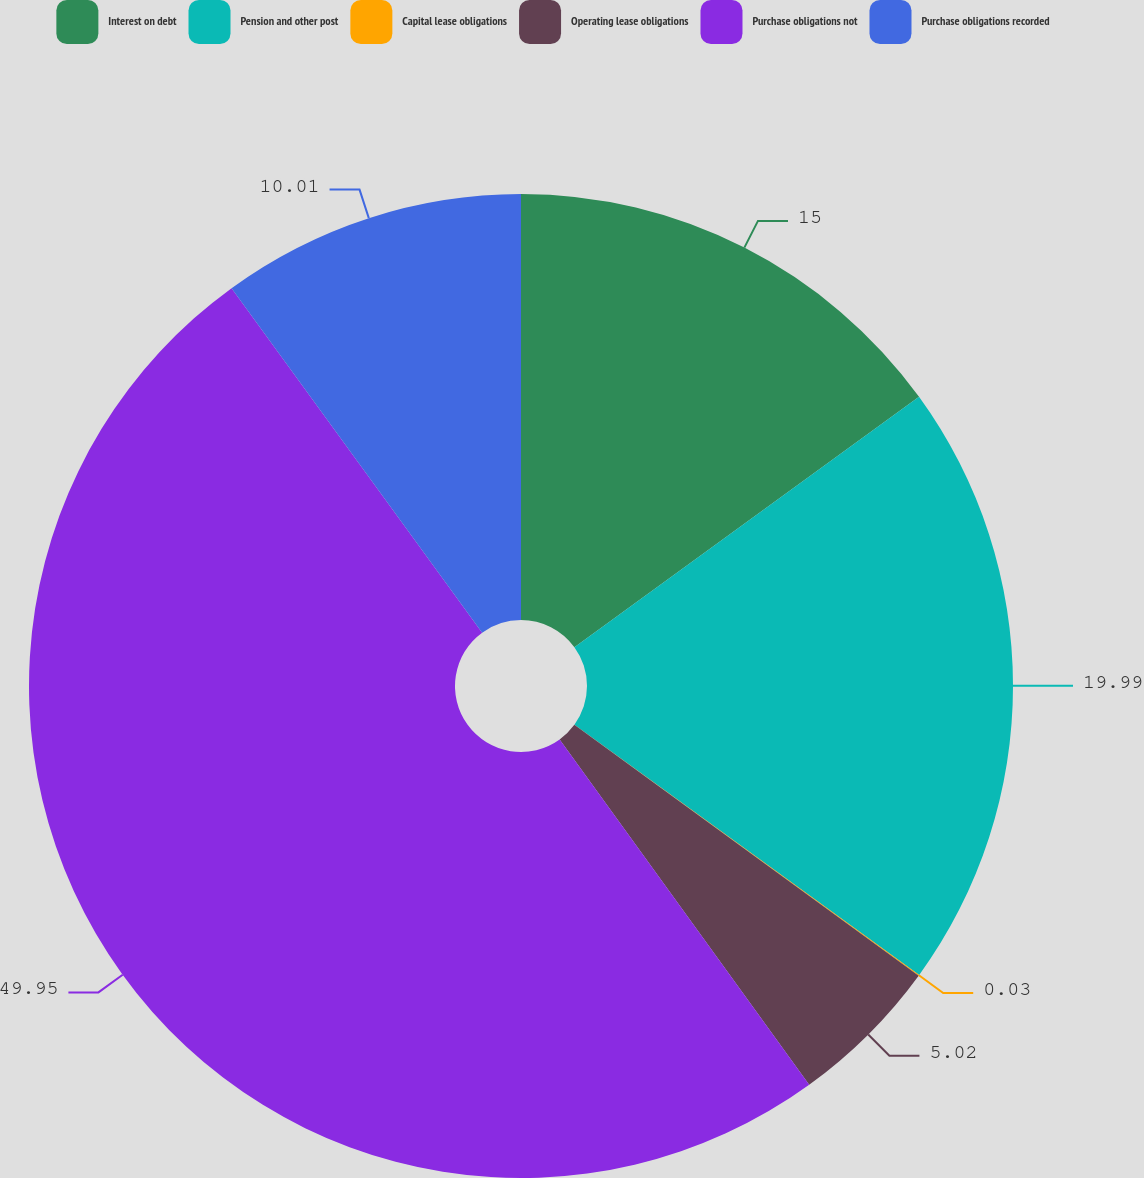Convert chart. <chart><loc_0><loc_0><loc_500><loc_500><pie_chart><fcel>Interest on debt<fcel>Pension and other post<fcel>Capital lease obligations<fcel>Operating lease obligations<fcel>Purchase obligations not<fcel>Purchase obligations recorded<nl><fcel>15.0%<fcel>19.99%<fcel>0.03%<fcel>5.02%<fcel>49.95%<fcel>10.01%<nl></chart> 